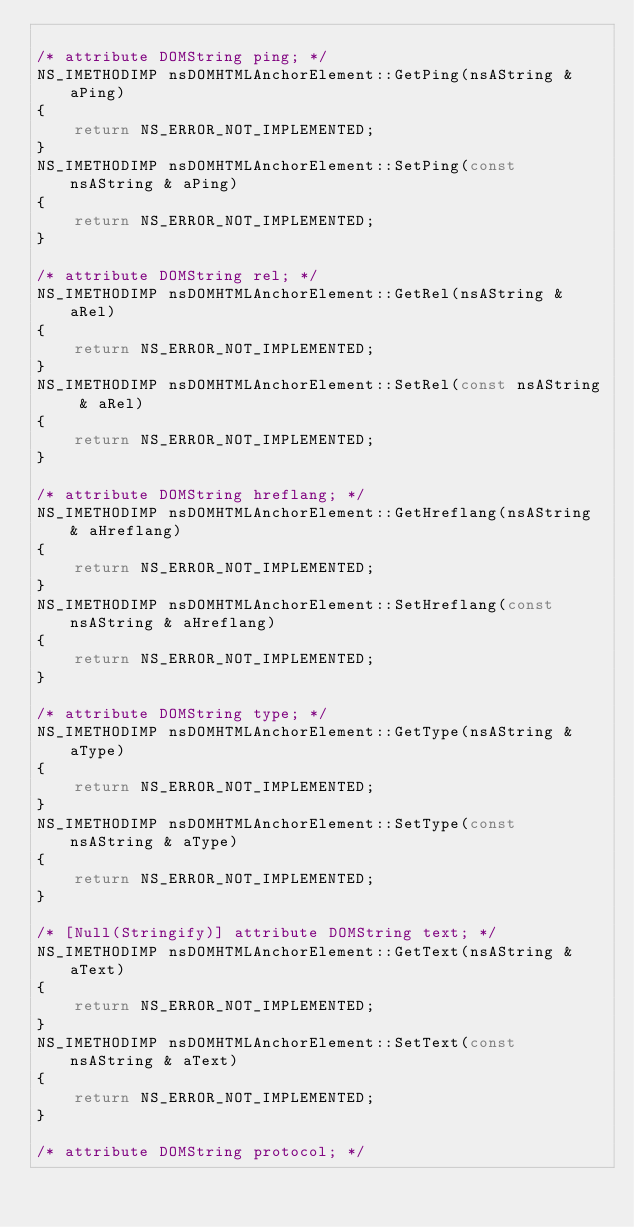Convert code to text. <code><loc_0><loc_0><loc_500><loc_500><_C_>
/* attribute DOMString ping; */
NS_IMETHODIMP nsDOMHTMLAnchorElement::GetPing(nsAString & aPing)
{
    return NS_ERROR_NOT_IMPLEMENTED;
}
NS_IMETHODIMP nsDOMHTMLAnchorElement::SetPing(const nsAString & aPing)
{
    return NS_ERROR_NOT_IMPLEMENTED;
}

/* attribute DOMString rel; */
NS_IMETHODIMP nsDOMHTMLAnchorElement::GetRel(nsAString & aRel)
{
    return NS_ERROR_NOT_IMPLEMENTED;
}
NS_IMETHODIMP nsDOMHTMLAnchorElement::SetRel(const nsAString & aRel)
{
    return NS_ERROR_NOT_IMPLEMENTED;
}

/* attribute DOMString hreflang; */
NS_IMETHODIMP nsDOMHTMLAnchorElement::GetHreflang(nsAString & aHreflang)
{
    return NS_ERROR_NOT_IMPLEMENTED;
}
NS_IMETHODIMP nsDOMHTMLAnchorElement::SetHreflang(const nsAString & aHreflang)
{
    return NS_ERROR_NOT_IMPLEMENTED;
}

/* attribute DOMString type; */
NS_IMETHODIMP nsDOMHTMLAnchorElement::GetType(nsAString & aType)
{
    return NS_ERROR_NOT_IMPLEMENTED;
}
NS_IMETHODIMP nsDOMHTMLAnchorElement::SetType(const nsAString & aType)
{
    return NS_ERROR_NOT_IMPLEMENTED;
}

/* [Null(Stringify)] attribute DOMString text; */
NS_IMETHODIMP nsDOMHTMLAnchorElement::GetText(nsAString & aText)
{
    return NS_ERROR_NOT_IMPLEMENTED;
}
NS_IMETHODIMP nsDOMHTMLAnchorElement::SetText(const nsAString & aText)
{
    return NS_ERROR_NOT_IMPLEMENTED;
}

/* attribute DOMString protocol; */</code> 